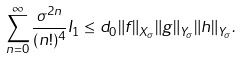Convert formula to latex. <formula><loc_0><loc_0><loc_500><loc_500>\sum _ { n = 0 } ^ { \infty } \frac { \sigma ^ { 2 n } } { ( n ! ) ^ { 4 } } I _ { 1 } \leq d _ { 0 } \| f \| _ { X _ { \sigma } } \| g \| _ { Y _ { \sigma } } \| h \| _ { Y _ { \sigma } } .</formula> 